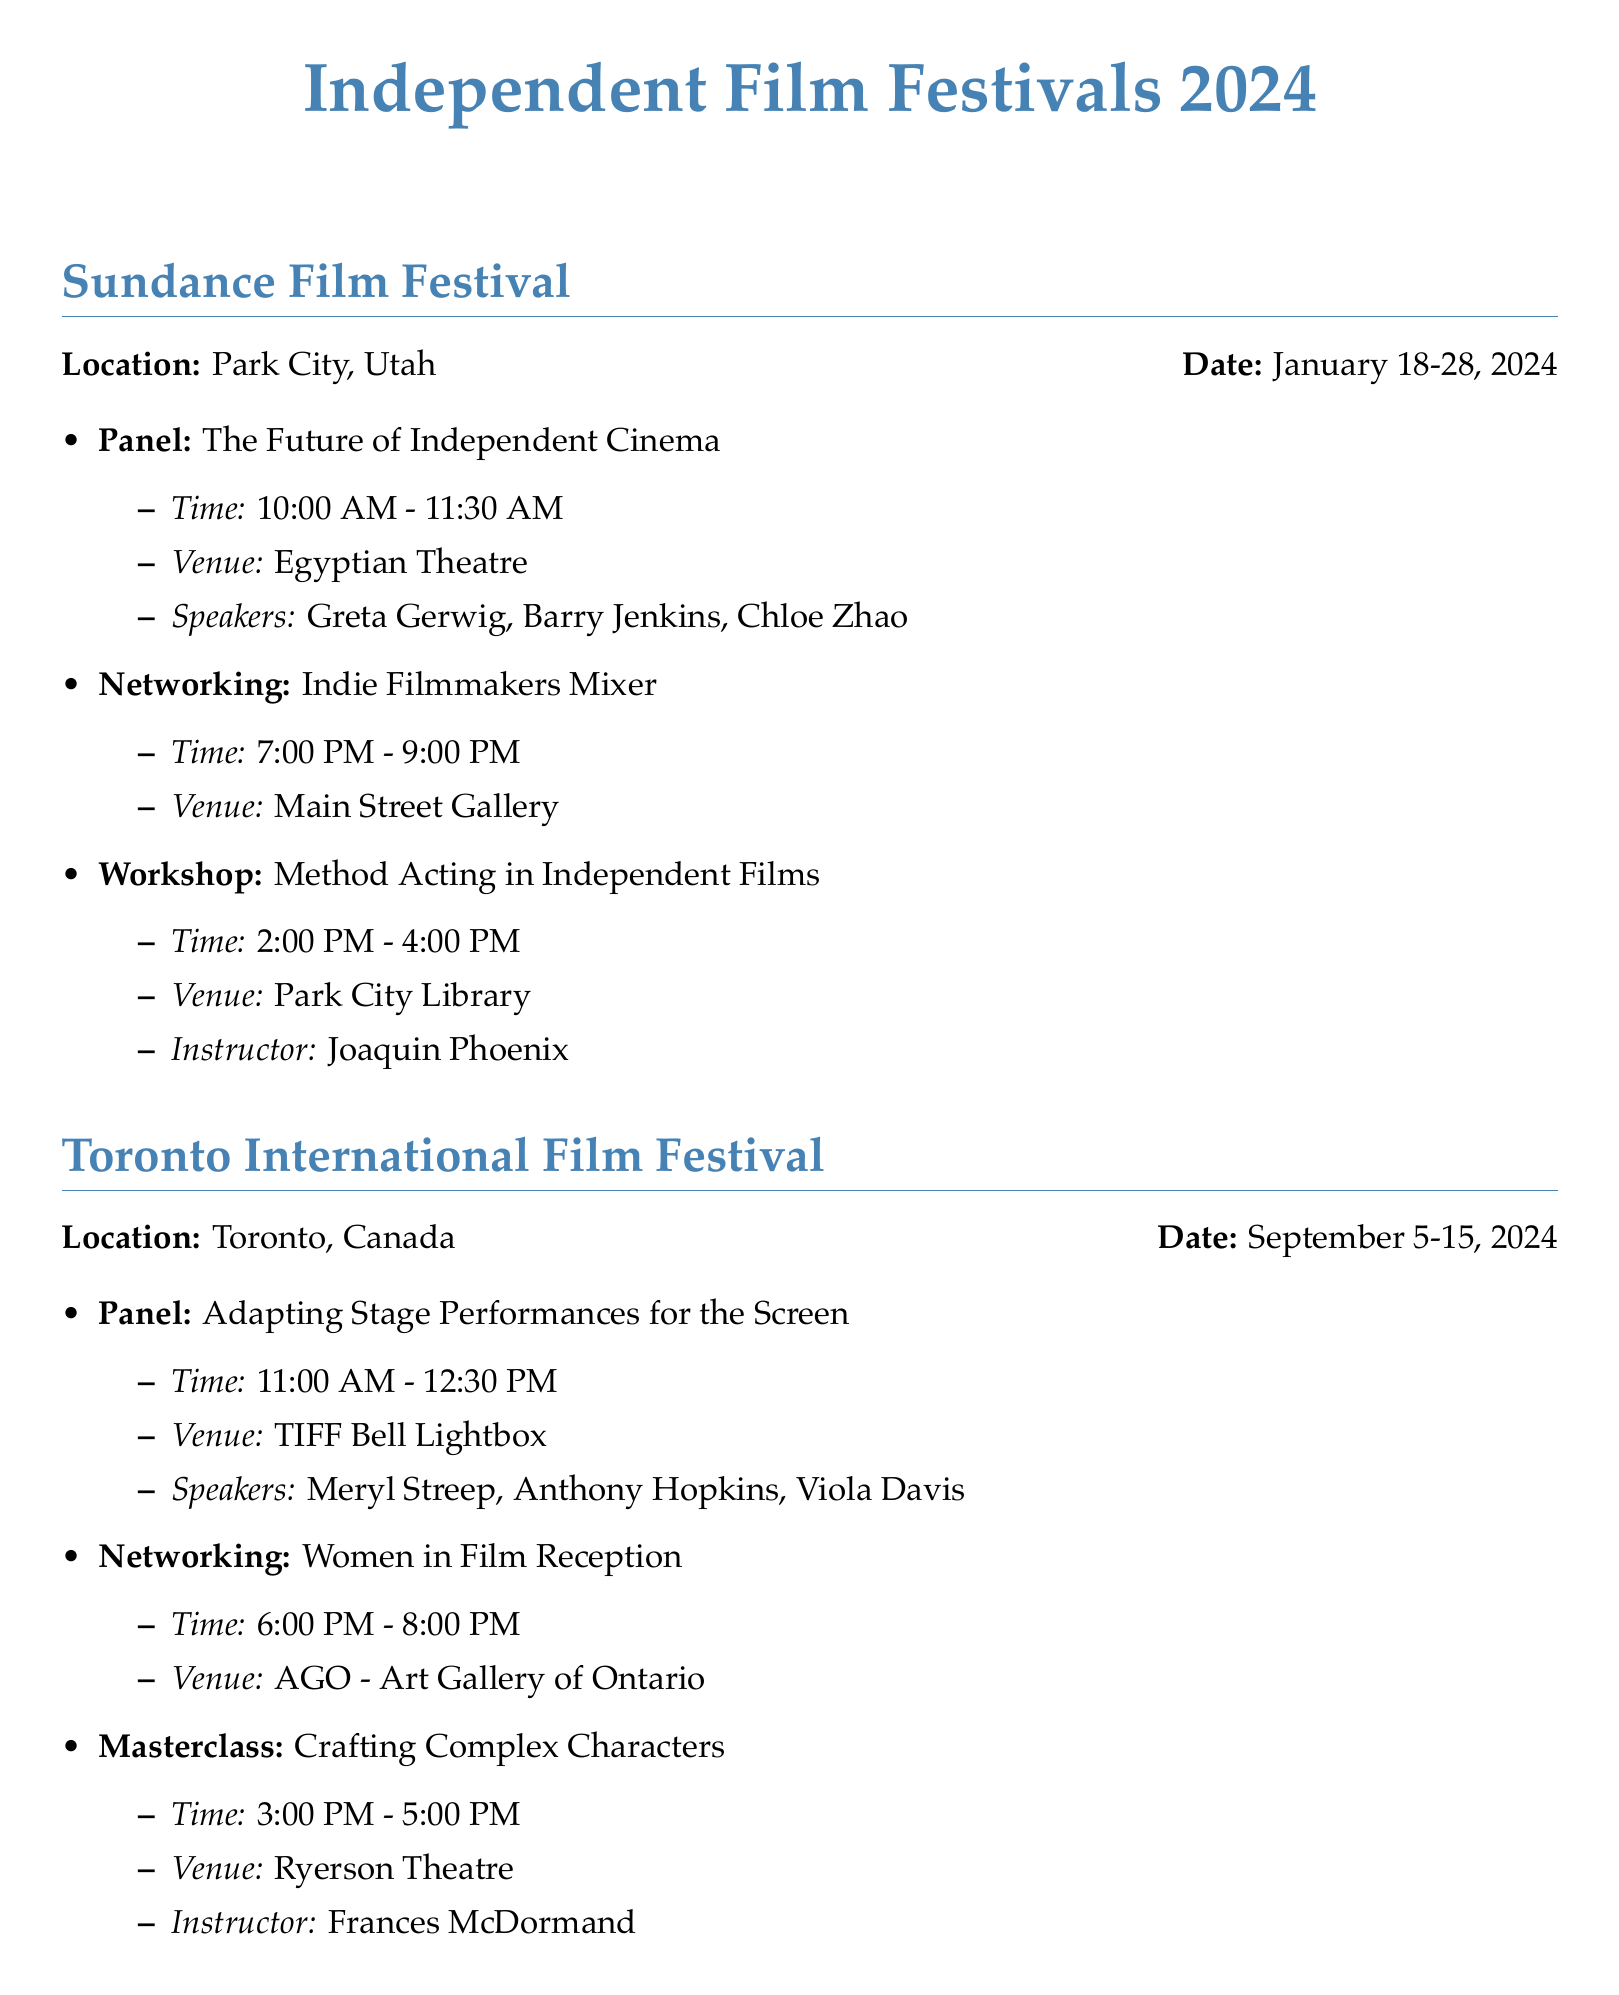What is the location of the Sundance Film Festival? The location for the Sundance Film Festival is specifically listed as Park City, Utah in the document.
Answer: Park City, Utah Who are the speakers for the panel discussion on "The Future of Independent Cinema"? The document lists Greta Gerwig, Barry Jenkins, and Chloe Zhao as the speakers for this specific panel discussion.
Answer: Greta Gerwig, Barry Jenkins, Chloe Zhao What is the time for the "Women in Film Reception" networking event? The time for this event is mentioned clearly in the document as 6:00 PM to 8:00 PM.
Answer: 6:00 PM - 8:00 PM Which venue hosts the "New York Indie Film Soiree"? The venue for this networking event is specified in the document as Tribeca Rooftop.
Answer: Tribeca Rooftop What type of event is scheduled from 10:00 AM to 11:30 AM at the Toronto International Film Festival? The event type matching this time is identified in the document as a Panel Discussion.
Answer: Panel Discussion How many total major film festivals are listed in the document? The document lists three major independent film festivals and asks about their unique details.
Answer: 3 Who is the instructor for the "Method Acting in Independent Films" workshop? The document clearly states Joaquin Phoenix as the instructor for this particular workshop.
Answer: Joaquin Phoenix What is the title of the pitch competition at the Tribeca Film Festival? The title for this pitch competition is given in the document as "Tribeca All Access."
Answer: Tribeca All Access What is the date range for the Toronto International Film Festival? The document directly specifies that this festival takes place from September 5 to September 15, 2024.
Answer: September 5-15, 2024 